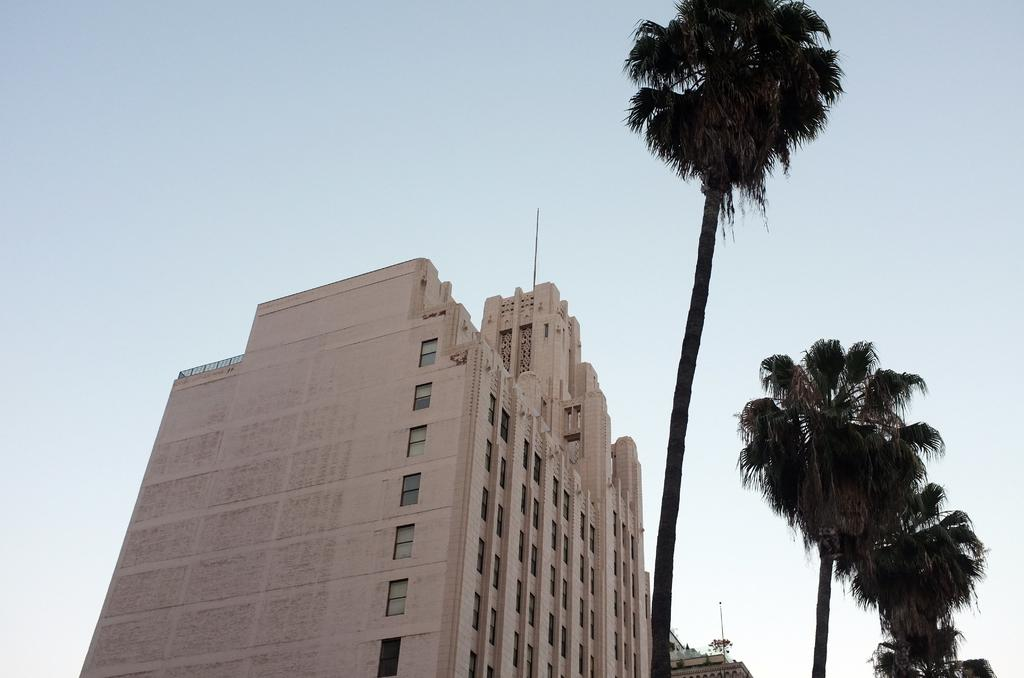What structure is located on the bottom left side of the image? There is a building on the bottom left side of the image. What type of vegetation is on the bottom right side of the image? There are trees on the bottom right side of the image. What is visible at the top of the image? The sky is visible at the top of the image. What type of instrument is being played in the room depicted in the image? There is no room or instrument present in the image; it features a building, trees, and the sky. Can you tell me what flavor the cake is in the image? There is no cake present in the image. 